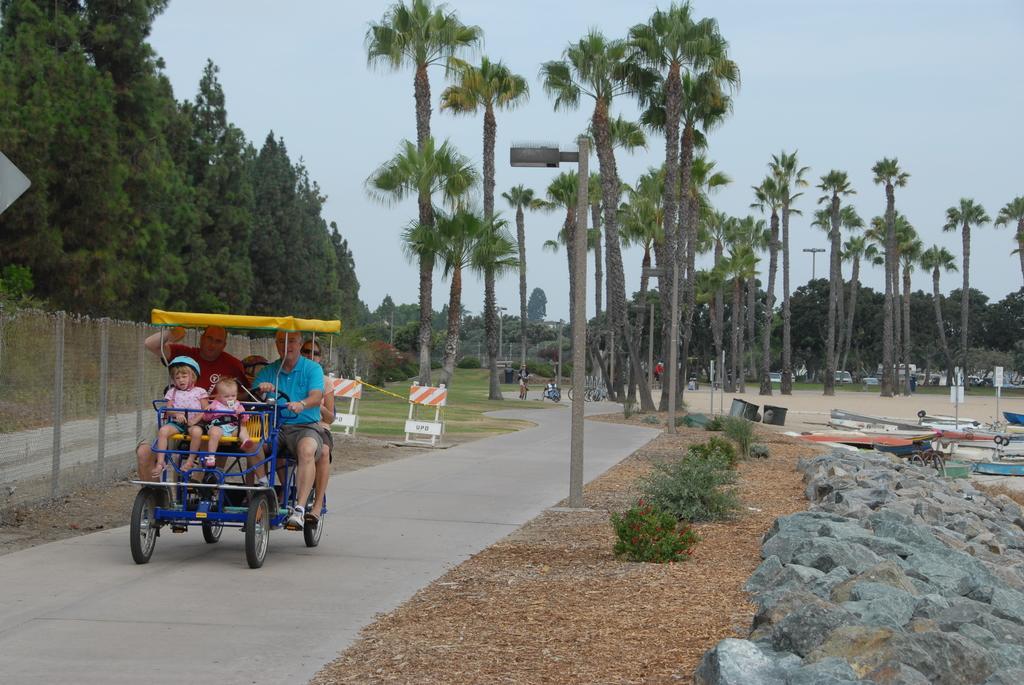Describe this image in one or two sentences. In this picture there is a man who is wearing t-shirt, short and shoe. He is riding a vehicle, beside him there is another man who is wearing red t-shirt and trouser. At back there is a woman who is sitting on the seat. In front of them there are two girls were sitting on the yellow seat. On the right I can see many boats on the beach. In the back I can see some peoples were standing near to the trees and bicycle. On the right background I can see many cars, bus and other vehicles were parked near to the trees. On the left there is fencing. At the top there is a sky. 